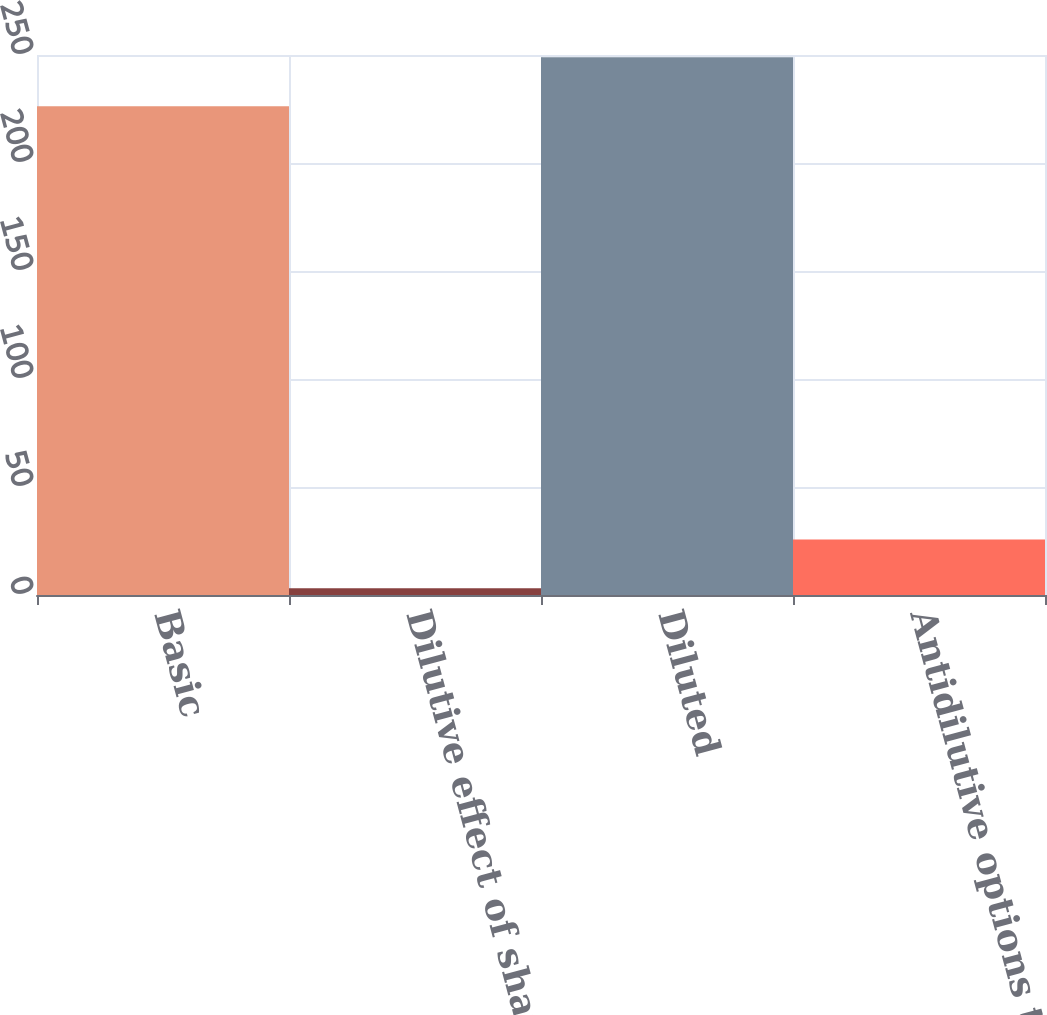Convert chart to OTSL. <chart><loc_0><loc_0><loc_500><loc_500><bar_chart><fcel>Basic<fcel>Dilutive effect of shares<fcel>Diluted<fcel>Antidilutive options to<nl><fcel>226.3<fcel>3.1<fcel>248.93<fcel>25.73<nl></chart> 